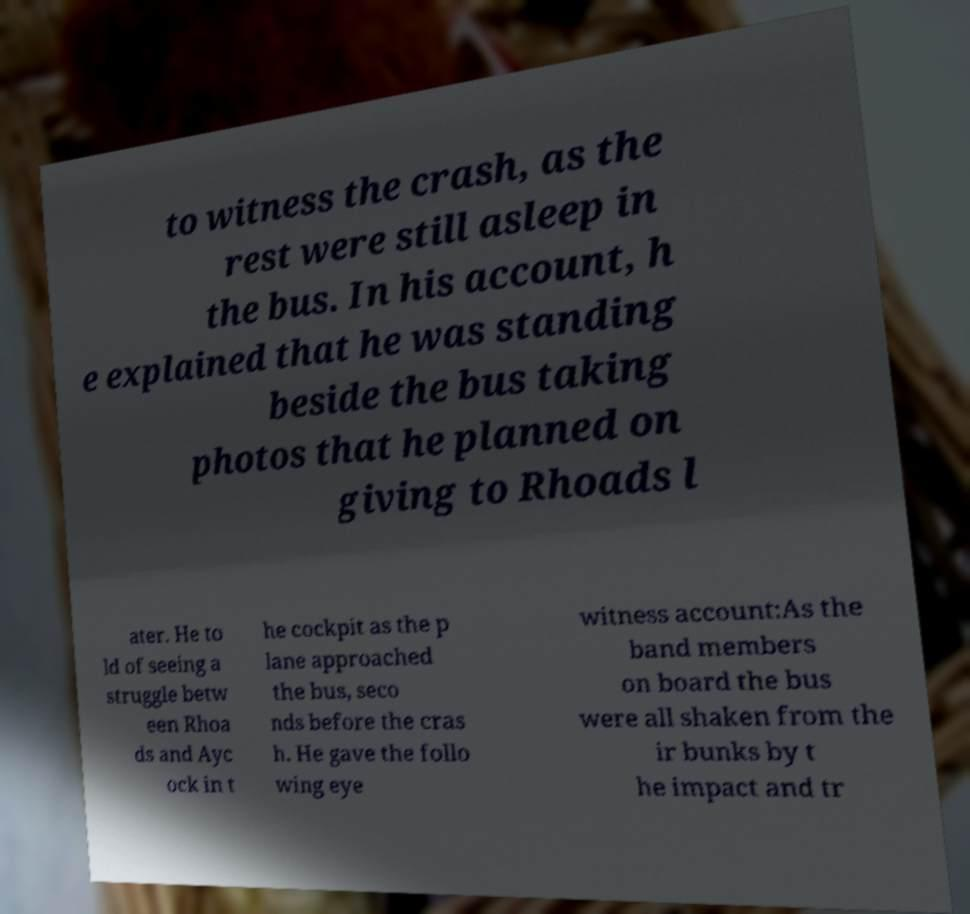Could you extract and type out the text from this image? to witness the crash, as the rest were still asleep in the bus. In his account, h e explained that he was standing beside the bus taking photos that he planned on giving to Rhoads l ater. He to ld of seeing a struggle betw een Rhoa ds and Ayc ock in t he cockpit as the p lane approached the bus, seco nds before the cras h. He gave the follo wing eye witness account:As the band members on board the bus were all shaken from the ir bunks by t he impact and tr 